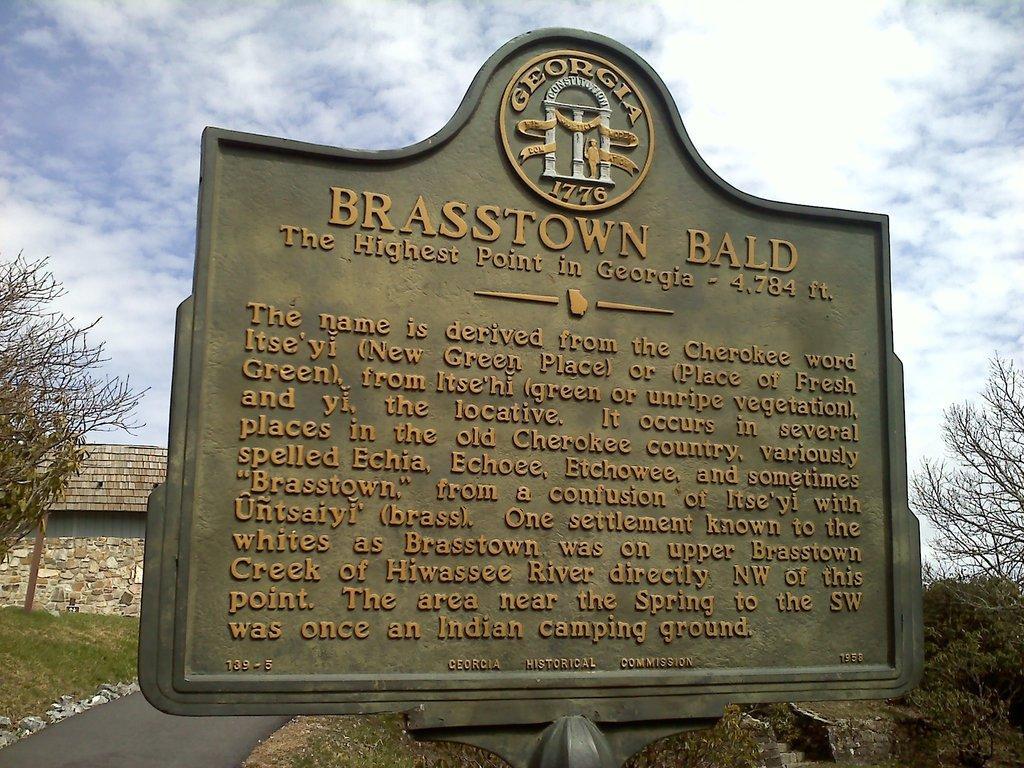Can you describe this image briefly? In this picture we can see a board and few stones on the path. We can see a compound wall, building and few trees in the background. 